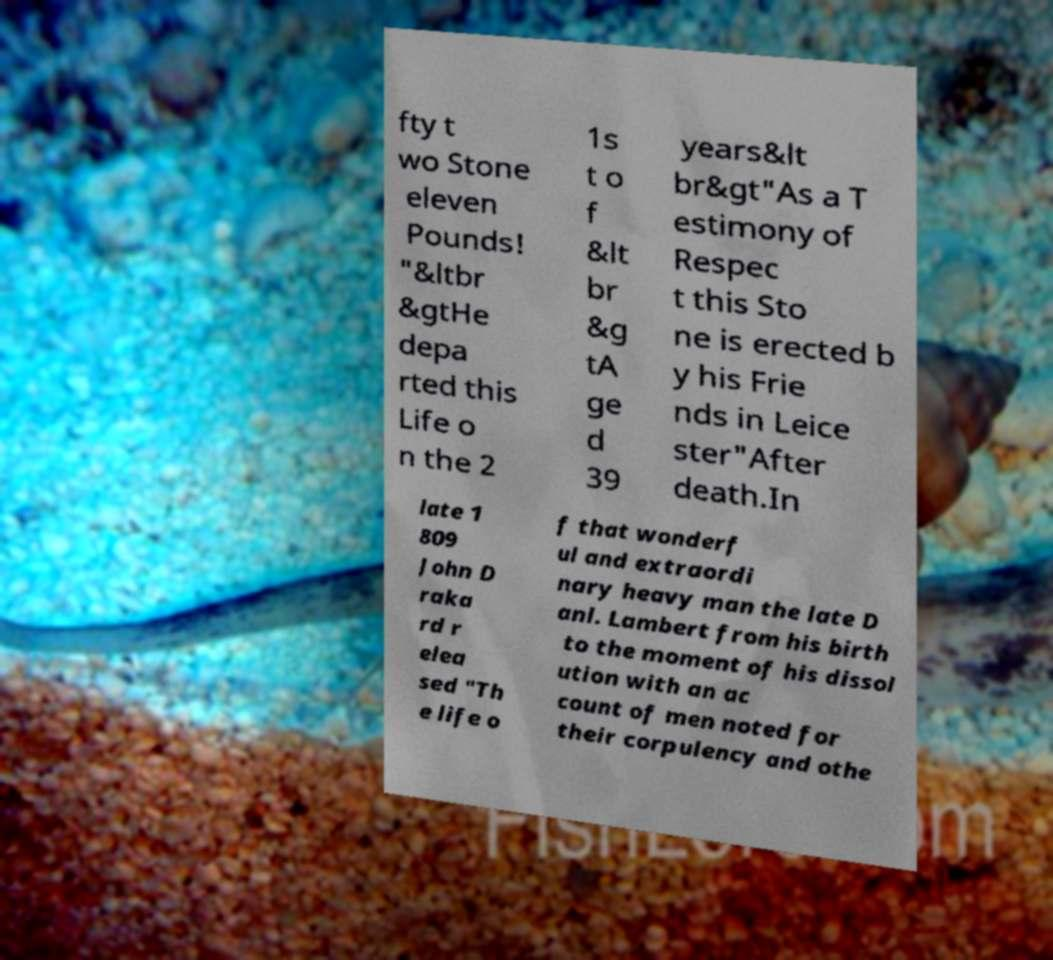Can you accurately transcribe the text from the provided image for me? fty t wo Stone eleven Pounds! "&ltbr &gtHe depa rted this Life o n the 2 1s t o f &lt br &g tA ge d 39 years&lt br&gt"As a T estimony of Respec t this Sto ne is erected b y his Frie nds in Leice ster"After death.In late 1 809 John D raka rd r elea sed "Th e life o f that wonderf ul and extraordi nary heavy man the late D anl. Lambert from his birth to the moment of his dissol ution with an ac count of men noted for their corpulency and othe 